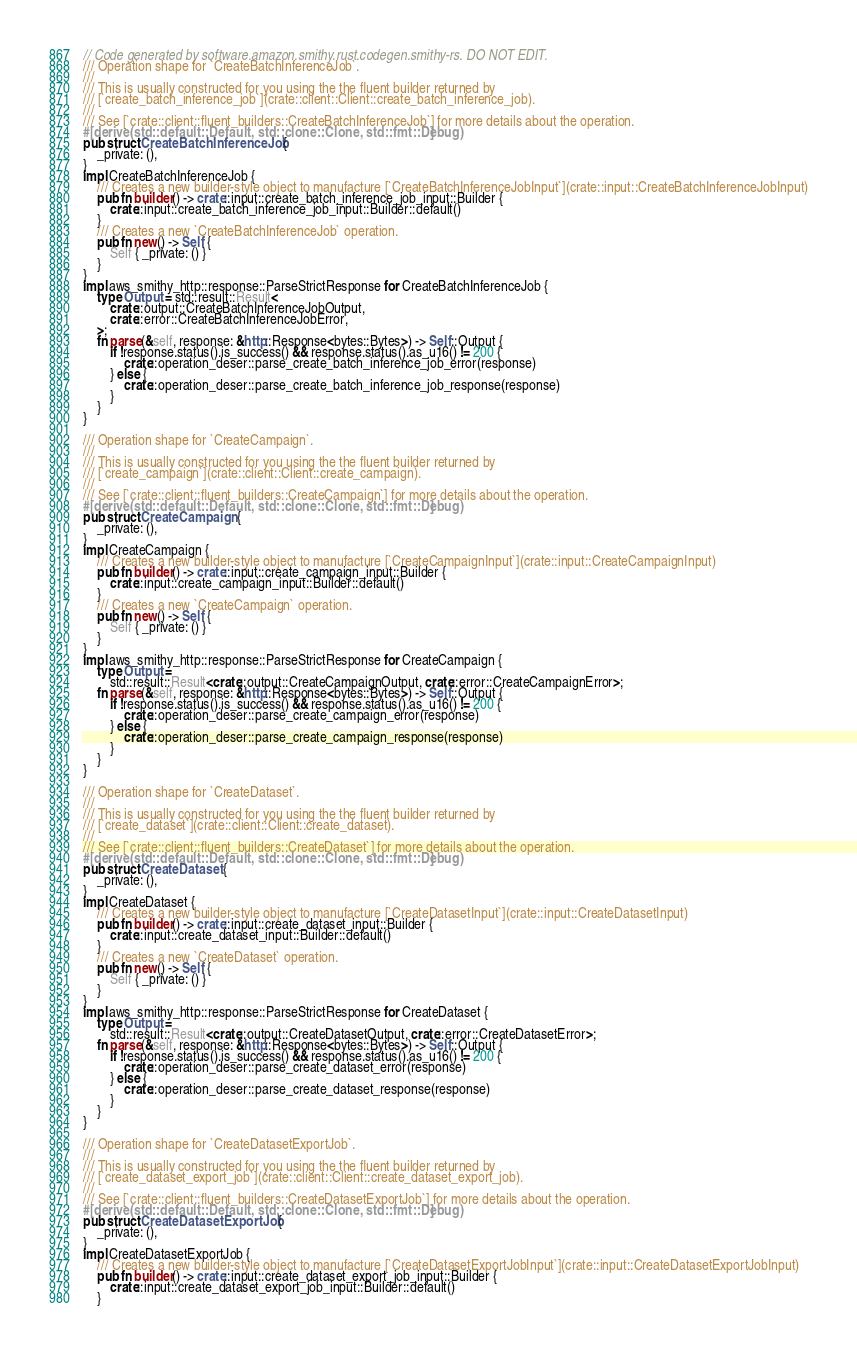Convert code to text. <code><loc_0><loc_0><loc_500><loc_500><_Rust_>// Code generated by software.amazon.smithy.rust.codegen.smithy-rs. DO NOT EDIT.
/// Operation shape for `CreateBatchInferenceJob`.
///
/// This is usually constructed for you using the the fluent builder returned by
/// [`create_batch_inference_job`](crate::client::Client::create_batch_inference_job).
///
/// See [`crate::client::fluent_builders::CreateBatchInferenceJob`] for more details about the operation.
#[derive(std::default::Default, std::clone::Clone, std::fmt::Debug)]
pub struct CreateBatchInferenceJob {
    _private: (),
}
impl CreateBatchInferenceJob {
    /// Creates a new builder-style object to manufacture [`CreateBatchInferenceJobInput`](crate::input::CreateBatchInferenceJobInput)
    pub fn builder() -> crate::input::create_batch_inference_job_input::Builder {
        crate::input::create_batch_inference_job_input::Builder::default()
    }
    /// Creates a new `CreateBatchInferenceJob` operation.
    pub fn new() -> Self {
        Self { _private: () }
    }
}
impl aws_smithy_http::response::ParseStrictResponse for CreateBatchInferenceJob {
    type Output = std::result::Result<
        crate::output::CreateBatchInferenceJobOutput,
        crate::error::CreateBatchInferenceJobError,
    >;
    fn parse(&self, response: &http::Response<bytes::Bytes>) -> Self::Output {
        if !response.status().is_success() && response.status().as_u16() != 200 {
            crate::operation_deser::parse_create_batch_inference_job_error(response)
        } else {
            crate::operation_deser::parse_create_batch_inference_job_response(response)
        }
    }
}

/// Operation shape for `CreateCampaign`.
///
/// This is usually constructed for you using the the fluent builder returned by
/// [`create_campaign`](crate::client::Client::create_campaign).
///
/// See [`crate::client::fluent_builders::CreateCampaign`] for more details about the operation.
#[derive(std::default::Default, std::clone::Clone, std::fmt::Debug)]
pub struct CreateCampaign {
    _private: (),
}
impl CreateCampaign {
    /// Creates a new builder-style object to manufacture [`CreateCampaignInput`](crate::input::CreateCampaignInput)
    pub fn builder() -> crate::input::create_campaign_input::Builder {
        crate::input::create_campaign_input::Builder::default()
    }
    /// Creates a new `CreateCampaign` operation.
    pub fn new() -> Self {
        Self { _private: () }
    }
}
impl aws_smithy_http::response::ParseStrictResponse for CreateCampaign {
    type Output =
        std::result::Result<crate::output::CreateCampaignOutput, crate::error::CreateCampaignError>;
    fn parse(&self, response: &http::Response<bytes::Bytes>) -> Self::Output {
        if !response.status().is_success() && response.status().as_u16() != 200 {
            crate::operation_deser::parse_create_campaign_error(response)
        } else {
            crate::operation_deser::parse_create_campaign_response(response)
        }
    }
}

/// Operation shape for `CreateDataset`.
///
/// This is usually constructed for you using the the fluent builder returned by
/// [`create_dataset`](crate::client::Client::create_dataset).
///
/// See [`crate::client::fluent_builders::CreateDataset`] for more details about the operation.
#[derive(std::default::Default, std::clone::Clone, std::fmt::Debug)]
pub struct CreateDataset {
    _private: (),
}
impl CreateDataset {
    /// Creates a new builder-style object to manufacture [`CreateDatasetInput`](crate::input::CreateDatasetInput)
    pub fn builder() -> crate::input::create_dataset_input::Builder {
        crate::input::create_dataset_input::Builder::default()
    }
    /// Creates a new `CreateDataset` operation.
    pub fn new() -> Self {
        Self { _private: () }
    }
}
impl aws_smithy_http::response::ParseStrictResponse for CreateDataset {
    type Output =
        std::result::Result<crate::output::CreateDatasetOutput, crate::error::CreateDatasetError>;
    fn parse(&self, response: &http::Response<bytes::Bytes>) -> Self::Output {
        if !response.status().is_success() && response.status().as_u16() != 200 {
            crate::operation_deser::parse_create_dataset_error(response)
        } else {
            crate::operation_deser::parse_create_dataset_response(response)
        }
    }
}

/// Operation shape for `CreateDatasetExportJob`.
///
/// This is usually constructed for you using the the fluent builder returned by
/// [`create_dataset_export_job`](crate::client::Client::create_dataset_export_job).
///
/// See [`crate::client::fluent_builders::CreateDatasetExportJob`] for more details about the operation.
#[derive(std::default::Default, std::clone::Clone, std::fmt::Debug)]
pub struct CreateDatasetExportJob {
    _private: (),
}
impl CreateDatasetExportJob {
    /// Creates a new builder-style object to manufacture [`CreateDatasetExportJobInput`](crate::input::CreateDatasetExportJobInput)
    pub fn builder() -> crate::input::create_dataset_export_job_input::Builder {
        crate::input::create_dataset_export_job_input::Builder::default()
    }</code> 